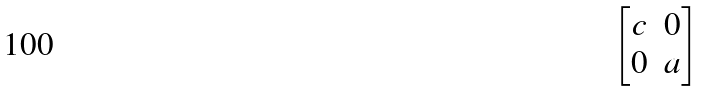<formula> <loc_0><loc_0><loc_500><loc_500>\begin{bmatrix} c & 0 \\ 0 & a \end{bmatrix}</formula> 